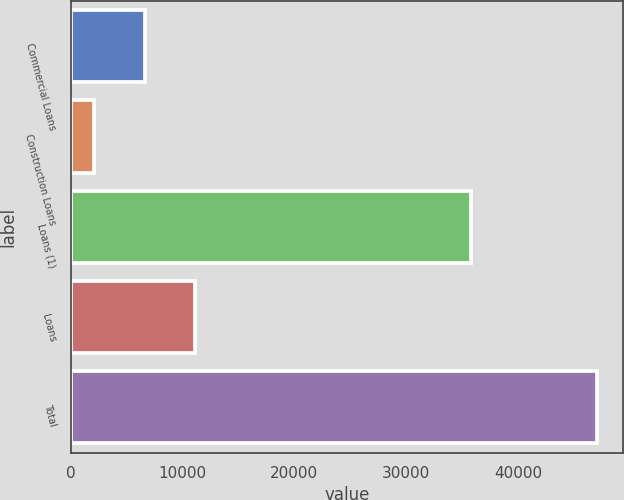Convert chart to OTSL. <chart><loc_0><loc_0><loc_500><loc_500><bar_chart><fcel>Commercial Loans<fcel>Construction Loans<fcel>Loans (1)<fcel>Loans<fcel>Total<nl><fcel>6611.1<fcel>2121<fcel>35766<fcel>11101.2<fcel>47022<nl></chart> 